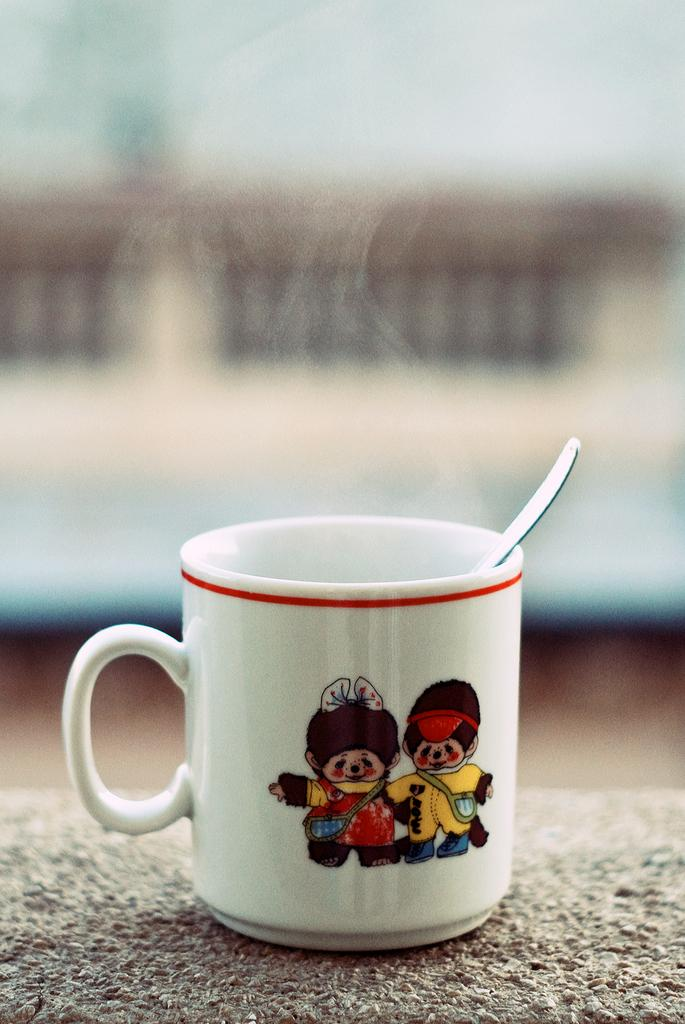What is in the image that people typically use for drinking? There is a coffee cup in the image. What is inside the coffee cup? There appears to be a spoon in the coffee cup. What design or artwork is on the coffee cup? The coffee cup has a painting on it. What type of committee is meeting in the image? There is no committee present in the image; it only features a coffee cup with a spoon and a painting on it. Can you see anyone skating or wearing boots in the image? There are no people or activities involving skating or boots in the image. 